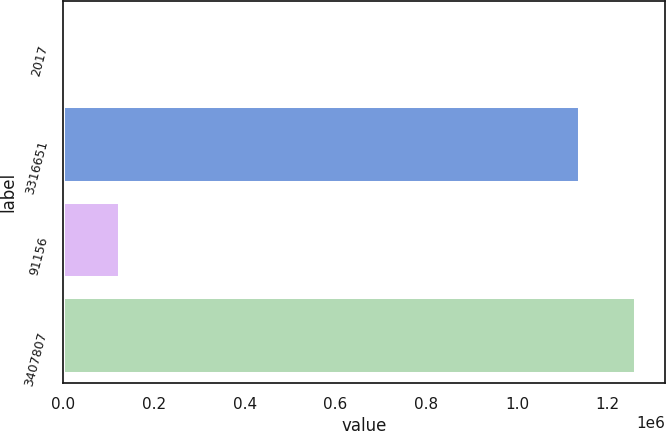<chart> <loc_0><loc_0><loc_500><loc_500><bar_chart><fcel>2017<fcel>3316651<fcel>91156<fcel>3407807<nl><fcel>2015<fcel>1.13997e+06<fcel>124770<fcel>1.26273e+06<nl></chart> 